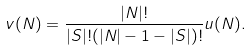<formula> <loc_0><loc_0><loc_500><loc_500>v ( N ) = \frac { | N | ! } { | S | ! ( | N | - 1 - | S | ) ! } u ( N ) .</formula> 